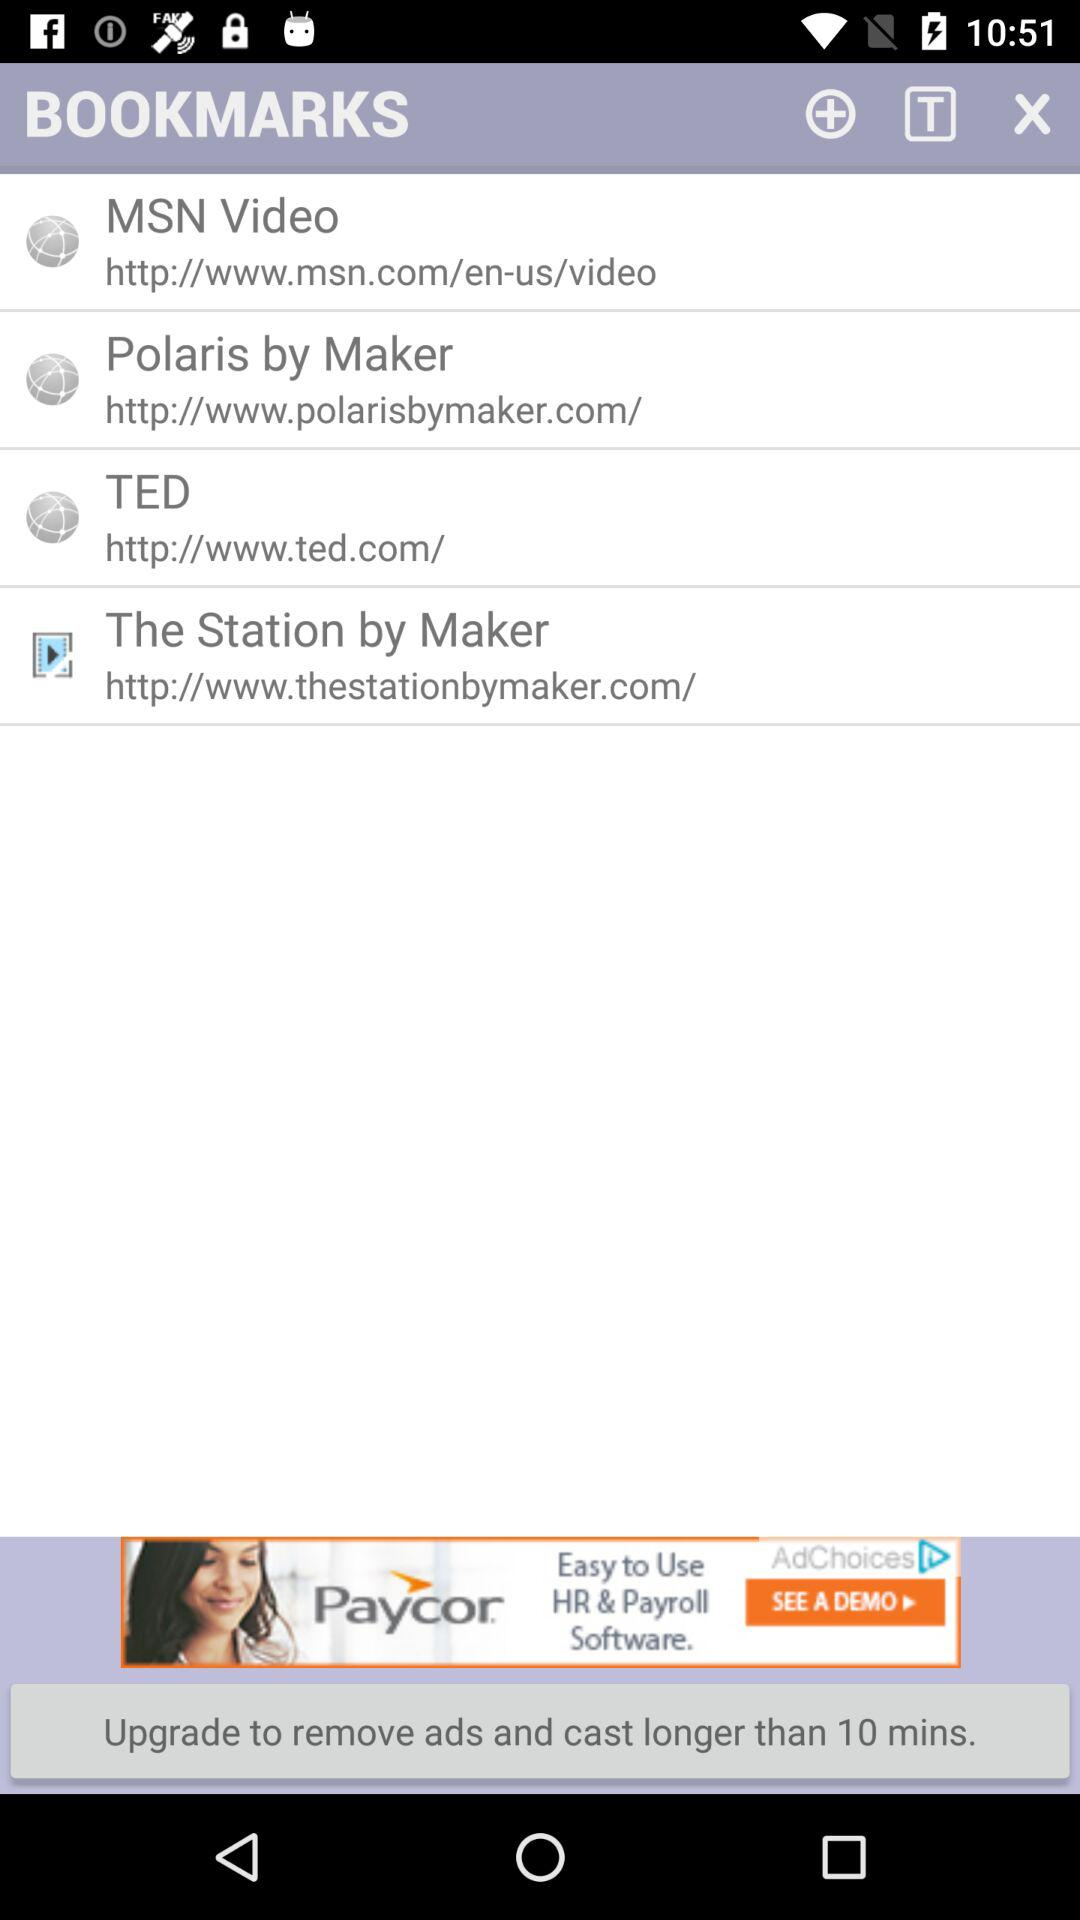10 minutes are given for what? 10 minutes are given to "Upgrade to remove ads and cast longer". 